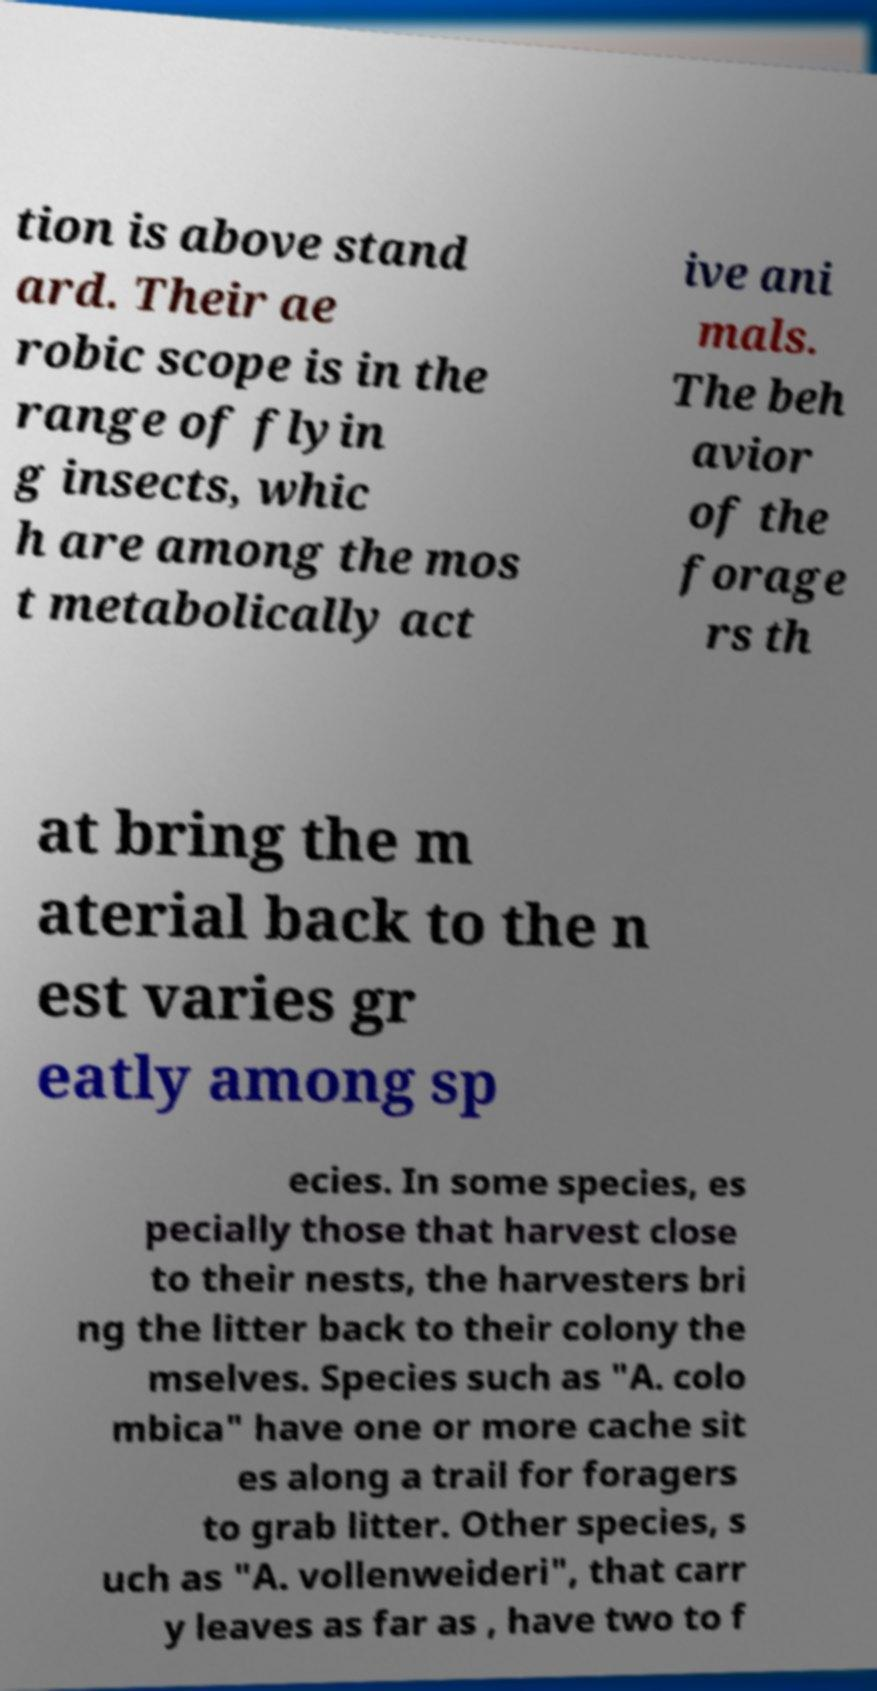Could you extract and type out the text from this image? tion is above stand ard. Their ae robic scope is in the range of flyin g insects, whic h are among the mos t metabolically act ive ani mals. The beh avior of the forage rs th at bring the m aterial back to the n est varies gr eatly among sp ecies. In some species, es pecially those that harvest close to their nests, the harvesters bri ng the litter back to their colony the mselves. Species such as "A. colo mbica" have one or more cache sit es along a trail for foragers to grab litter. Other species, s uch as "A. vollenweideri", that carr y leaves as far as , have two to f 